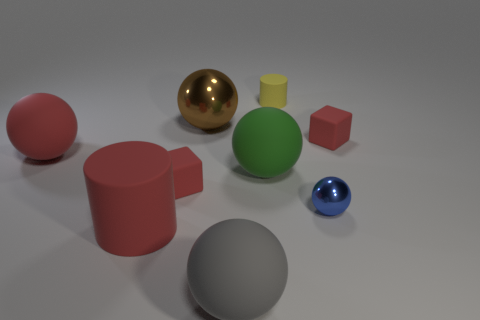Subtract 1 spheres. How many spheres are left? 4 Subtract all large metal balls. How many balls are left? 4 Subtract all blue balls. How many balls are left? 4 Add 1 red spheres. How many objects exist? 10 Subtract all red balls. Subtract all cyan blocks. How many balls are left? 4 Subtract all cylinders. How many objects are left? 7 Subtract 0 green blocks. How many objects are left? 9 Subtract all brown metal things. Subtract all large red cylinders. How many objects are left? 7 Add 1 red matte objects. How many red matte objects are left? 5 Add 5 tiny matte things. How many tiny matte things exist? 8 